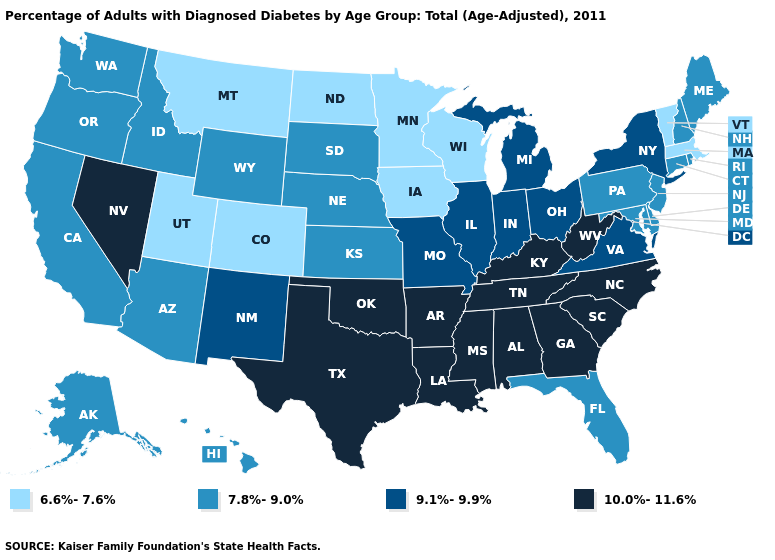What is the lowest value in the MidWest?
Answer briefly. 6.6%-7.6%. Does Mississippi have a higher value than Massachusetts?
Concise answer only. Yes. What is the value of Arkansas?
Write a very short answer. 10.0%-11.6%. Which states have the lowest value in the USA?
Quick response, please. Colorado, Iowa, Massachusetts, Minnesota, Montana, North Dakota, Utah, Vermont, Wisconsin. Does North Carolina have the lowest value in the South?
Write a very short answer. No. Is the legend a continuous bar?
Quick response, please. No. What is the value of Arkansas?
Keep it brief. 10.0%-11.6%. What is the lowest value in the West?
Give a very brief answer. 6.6%-7.6%. Does Louisiana have the highest value in the USA?
Quick response, please. Yes. Among the states that border South Carolina , which have the highest value?
Give a very brief answer. Georgia, North Carolina. Does Florida have the lowest value in the South?
Quick response, please. Yes. Name the states that have a value in the range 7.8%-9.0%?
Write a very short answer. Alaska, Arizona, California, Connecticut, Delaware, Florida, Hawaii, Idaho, Kansas, Maine, Maryland, Nebraska, New Hampshire, New Jersey, Oregon, Pennsylvania, Rhode Island, South Dakota, Washington, Wyoming. What is the highest value in states that border North Carolina?
Keep it brief. 10.0%-11.6%. Does the map have missing data?
Short answer required. No. Is the legend a continuous bar?
Write a very short answer. No. 